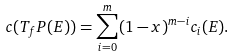<formula> <loc_0><loc_0><loc_500><loc_500>c ( T _ { f } P ( E ) ) = \sum _ { i = 0 } ^ { m } ( 1 - x ) ^ { m - i } c _ { i } ( E ) .</formula> 